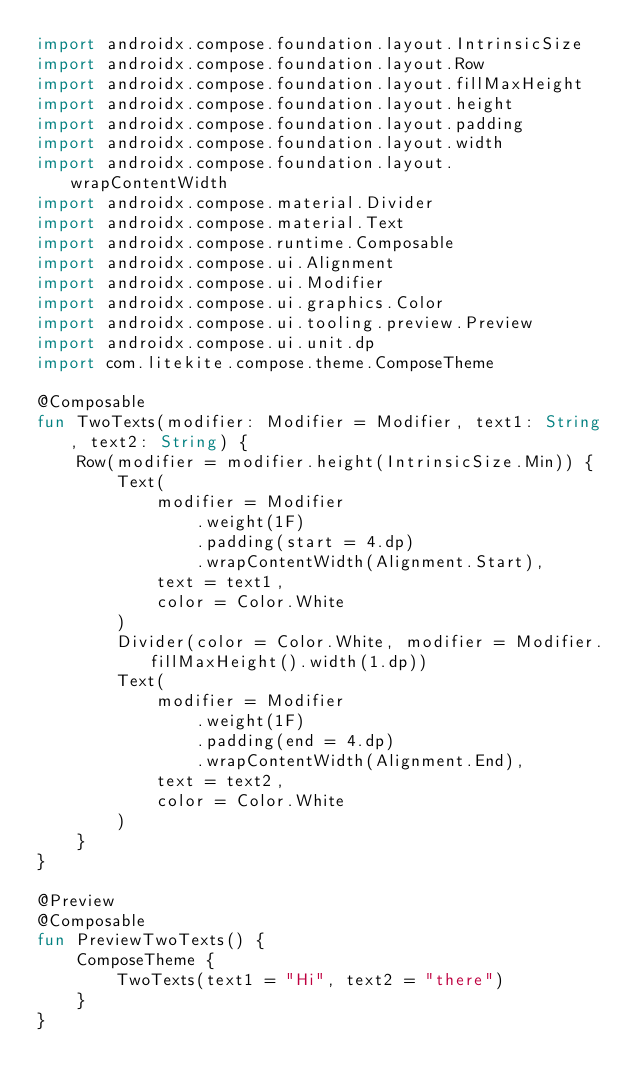Convert code to text. <code><loc_0><loc_0><loc_500><loc_500><_Kotlin_>import androidx.compose.foundation.layout.IntrinsicSize
import androidx.compose.foundation.layout.Row
import androidx.compose.foundation.layout.fillMaxHeight
import androidx.compose.foundation.layout.height
import androidx.compose.foundation.layout.padding
import androidx.compose.foundation.layout.width
import androidx.compose.foundation.layout.wrapContentWidth
import androidx.compose.material.Divider
import androidx.compose.material.Text
import androidx.compose.runtime.Composable
import androidx.compose.ui.Alignment
import androidx.compose.ui.Modifier
import androidx.compose.ui.graphics.Color
import androidx.compose.ui.tooling.preview.Preview
import androidx.compose.ui.unit.dp
import com.litekite.compose.theme.ComposeTheme

@Composable
fun TwoTexts(modifier: Modifier = Modifier, text1: String, text2: String) {
    Row(modifier = modifier.height(IntrinsicSize.Min)) {
        Text(
            modifier = Modifier
                .weight(1F)
                .padding(start = 4.dp)
                .wrapContentWidth(Alignment.Start),
            text = text1,
            color = Color.White
        )
        Divider(color = Color.White, modifier = Modifier.fillMaxHeight().width(1.dp))
        Text(
            modifier = Modifier
                .weight(1F)
                .padding(end = 4.dp)
                .wrapContentWidth(Alignment.End),
            text = text2,
            color = Color.White
        )
    }
}

@Preview
@Composable
fun PreviewTwoTexts() {
    ComposeTheme {
        TwoTexts(text1 = "Hi", text2 = "there")
    }
}
</code> 